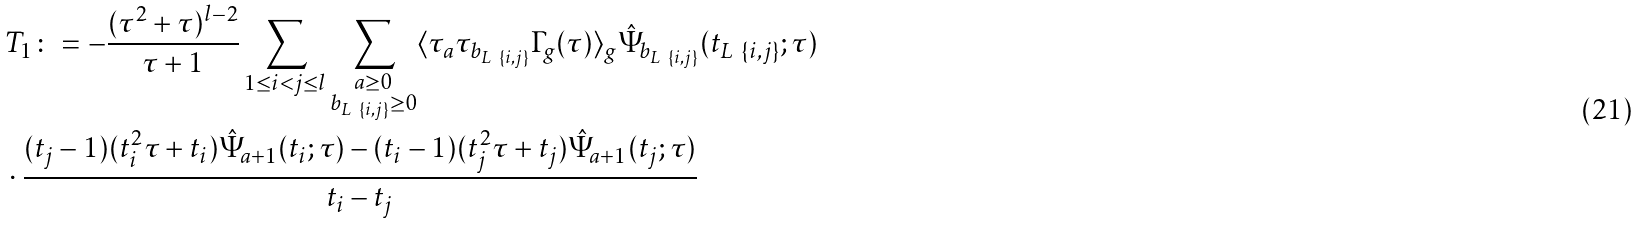<formula> <loc_0><loc_0><loc_500><loc_500>& T _ { 1 } \colon = - \frac { ( \tau ^ { 2 } + \tau ) ^ { l - 2 } } { \tau + 1 } \sum _ { 1 \leq i < j \leq l } \sum _ { \substack { a \geq 0 \\ b _ { L \ \{ i , j \} } \geq 0 } } \langle \tau _ { a } \tau _ { b _ { L \ \{ i , j \} } } \Gamma _ { g } ( \tau ) \rangle _ { g } \hat { \Psi } _ { b _ { L \ \{ i , j \} } } ( t _ { L \ \{ i , j \} } ; \tau ) \\ & \cdot \frac { ( t _ { j } - 1 ) ( t _ { i } ^ { 2 } \tau + t _ { i } ) \hat { \Psi } _ { a + 1 } ( t _ { i } ; \tau ) - ( t _ { i } - 1 ) ( t _ { j } ^ { 2 } \tau + t _ { j } ) \hat { \Psi } _ { a + 1 } ( t _ { j } ; \tau ) } { t _ { i } - t _ { j } }</formula> 